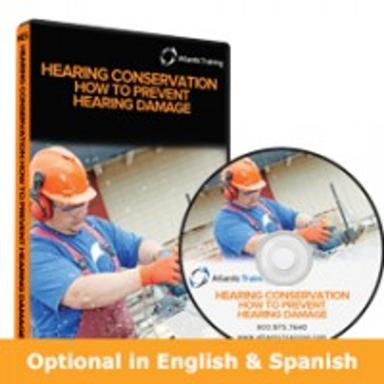In what languages is the DVD available? The DVD is available in both English and Spanish. This bilingual option ensures wider accessibility, allowing for effective training in diverse workforces as seen in manufacturing sectors similar to the one depicted on the DVD cover. 